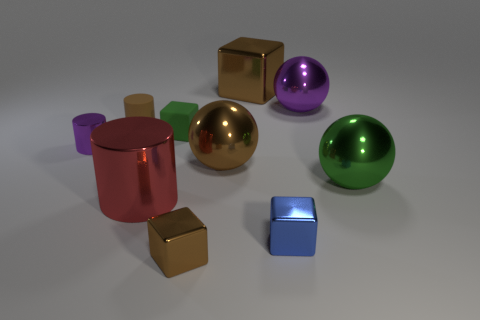Subtract all small cylinders. How many cylinders are left? 1 Subtract all purple balls. How many brown cubes are left? 2 Subtract all purple cylinders. How many cylinders are left? 2 Subtract all blue cylinders. Subtract all gray spheres. How many cylinders are left? 3 Subtract all blocks. How many objects are left? 6 Add 2 shiny spheres. How many shiny spheres are left? 5 Add 3 big red shiny cylinders. How many big red shiny cylinders exist? 4 Subtract 1 green balls. How many objects are left? 9 Subtract all small green matte objects. Subtract all tiny shiny things. How many objects are left? 6 